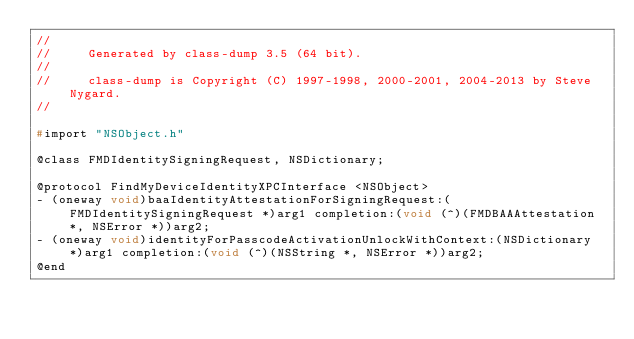<code> <loc_0><loc_0><loc_500><loc_500><_C_>//
//     Generated by class-dump 3.5 (64 bit).
//
//     class-dump is Copyright (C) 1997-1998, 2000-2001, 2004-2013 by Steve Nygard.
//

#import "NSObject.h"

@class FMDIdentitySigningRequest, NSDictionary;

@protocol FindMyDeviceIdentityXPCInterface <NSObject>
- (oneway void)baaIdentityAttestationForSigningRequest:(FMDIdentitySigningRequest *)arg1 completion:(void (^)(FMDBAAAttestation *, NSError *))arg2;
- (oneway void)identityForPasscodeActivationUnlockWithContext:(NSDictionary *)arg1 completion:(void (^)(NSString *, NSError *))arg2;
@end

</code> 